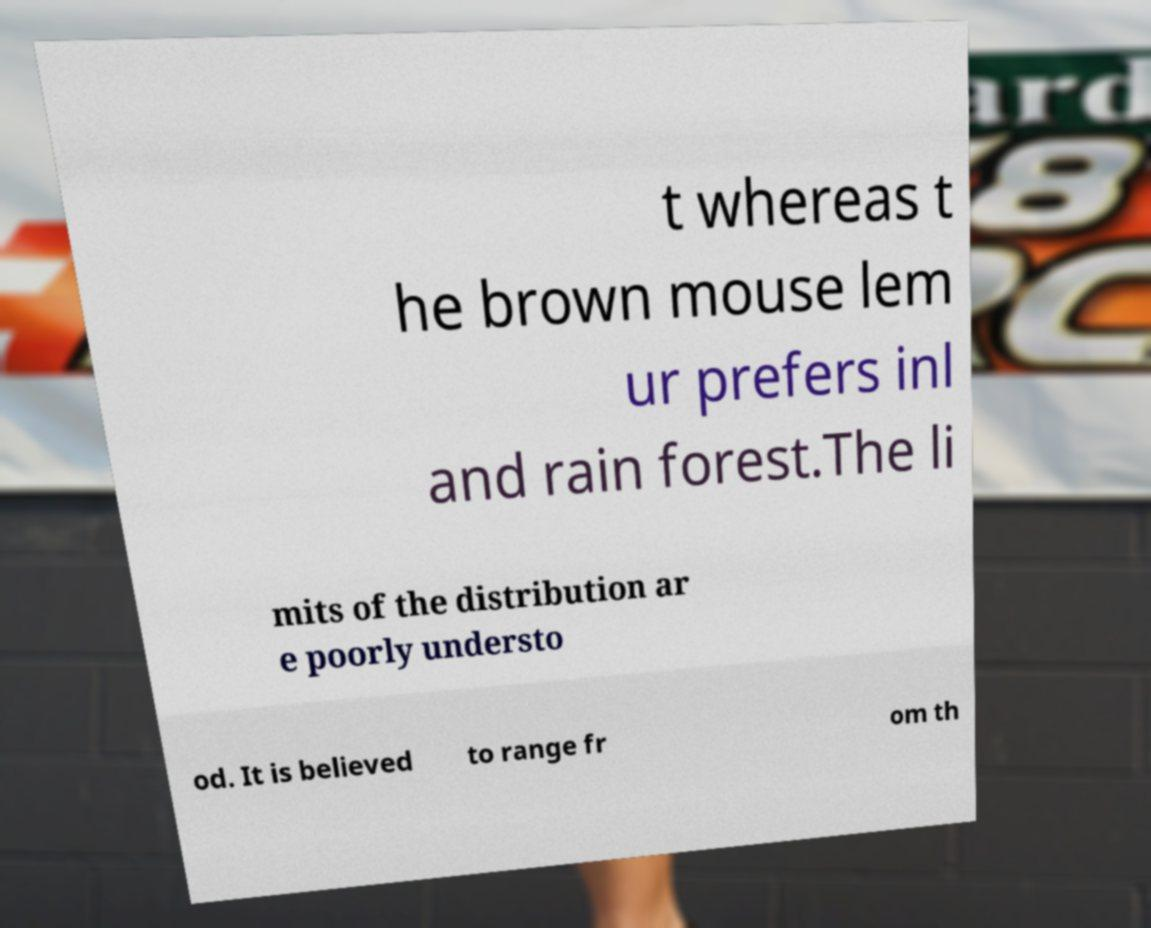What messages or text are displayed in this image? I need them in a readable, typed format. t whereas t he brown mouse lem ur prefers inl and rain forest.The li mits of the distribution ar e poorly understo od. It is believed to range fr om th 